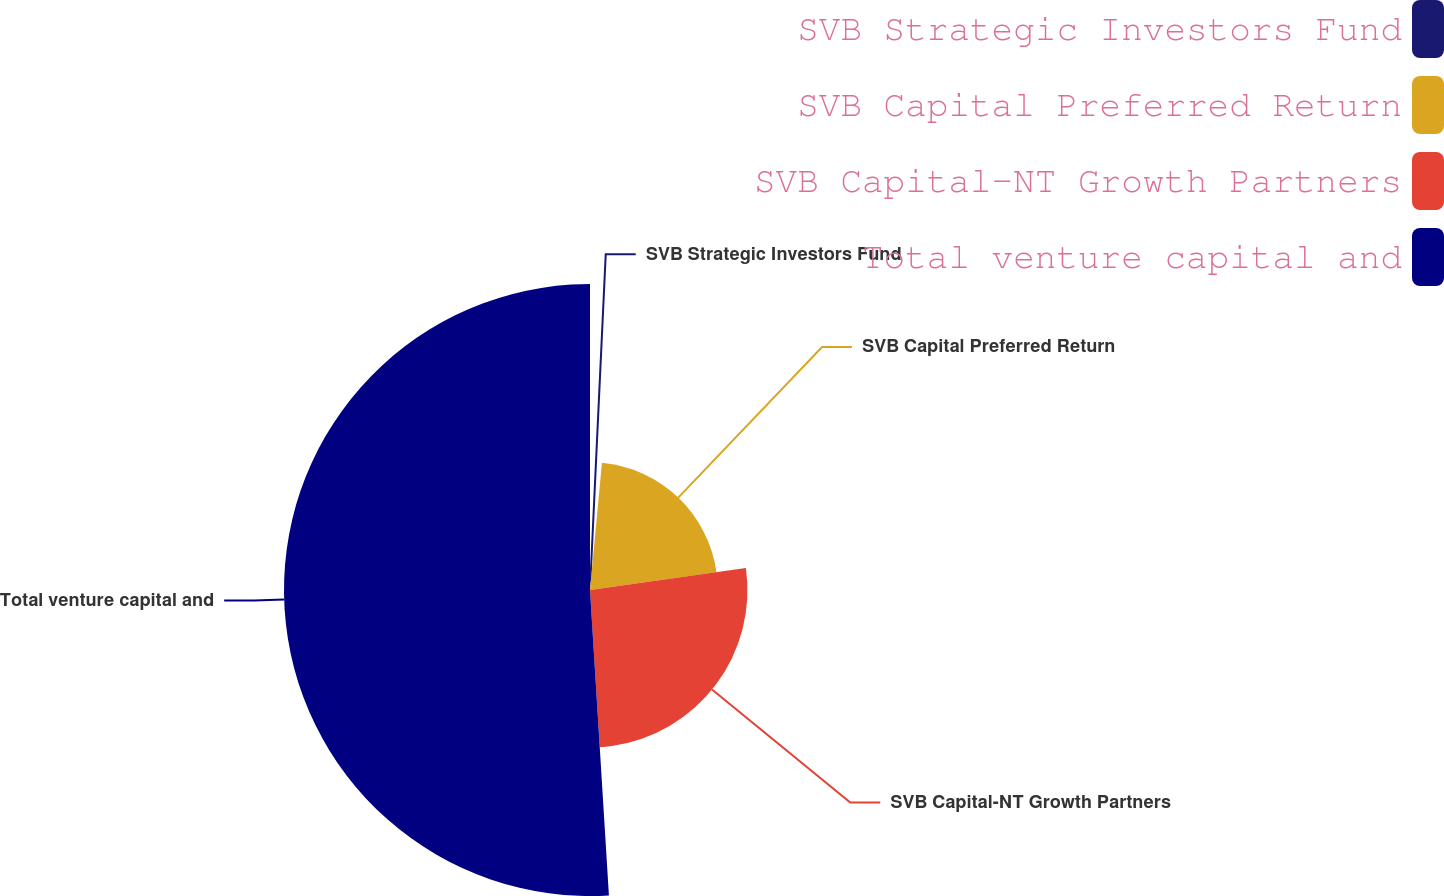Convert chart. <chart><loc_0><loc_0><loc_500><loc_500><pie_chart><fcel>SVB Strategic Investors Fund<fcel>SVB Capital Preferred Return<fcel>SVB Capital-NT Growth Partners<fcel>Total venture capital and<nl><fcel>1.49%<fcel>21.29%<fcel>26.24%<fcel>50.99%<nl></chart> 